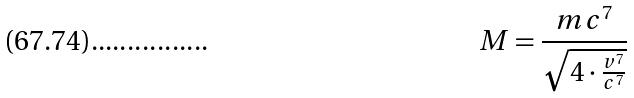Convert formula to latex. <formula><loc_0><loc_0><loc_500><loc_500>M = \frac { m c ^ { 7 } } { \sqrt { 4 \cdot \frac { v ^ { 7 } } { c ^ { 7 } } } }</formula> 